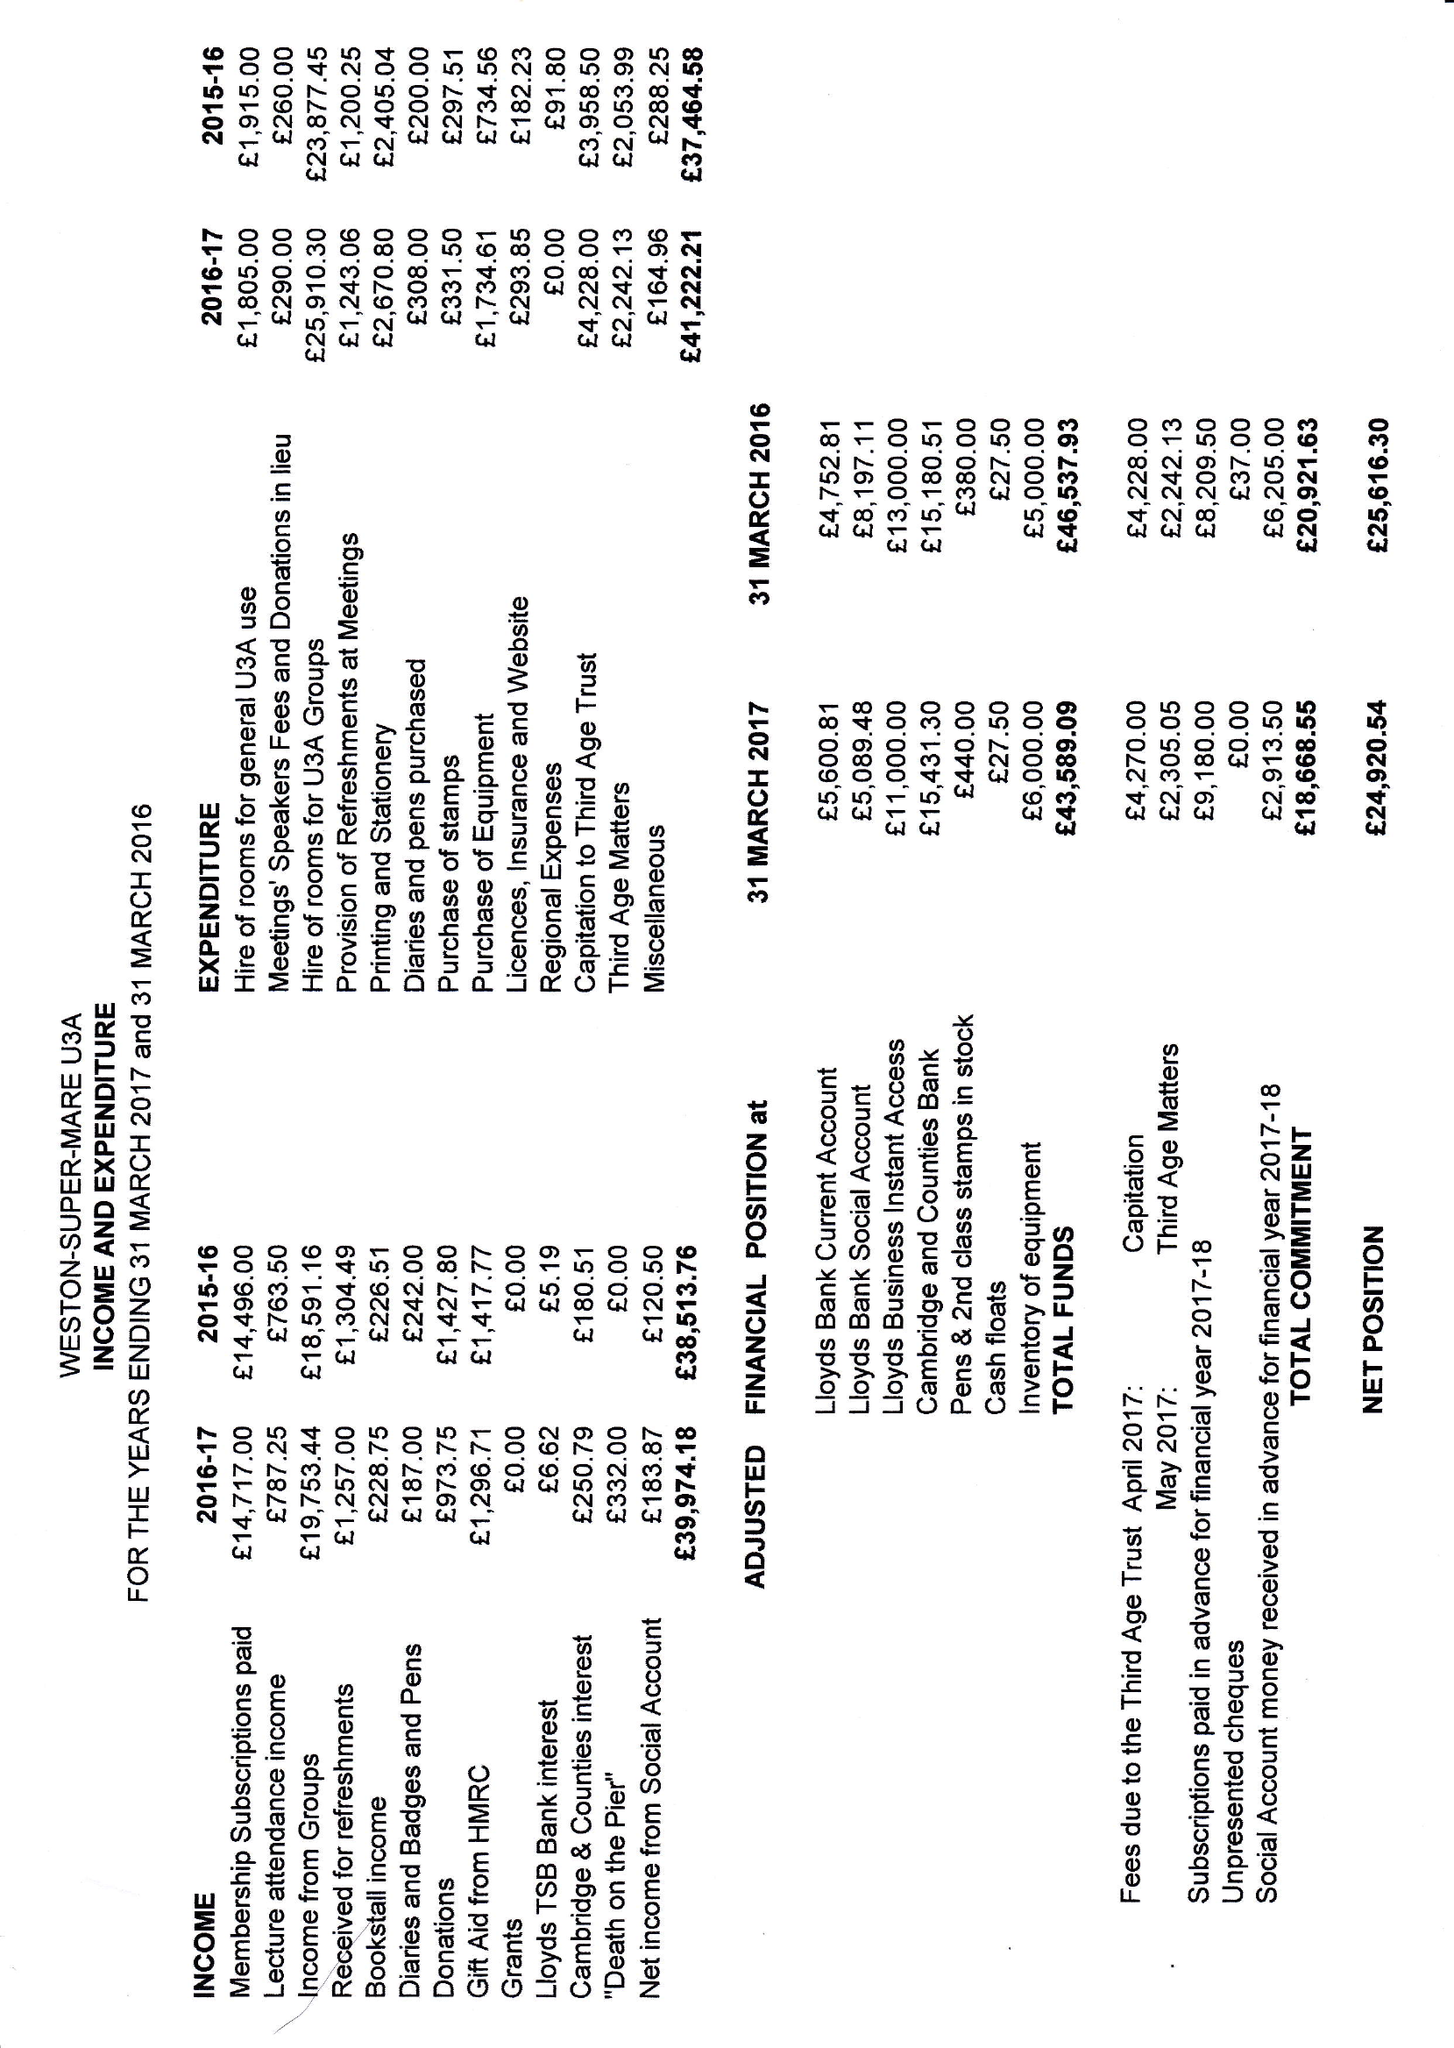What is the value for the charity_name?
Answer the question using a single word or phrase. Weston-Super-Mare U3a 